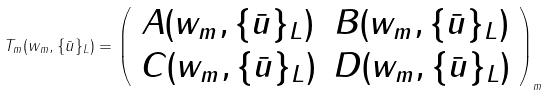<formula> <loc_0><loc_0><loc_500><loc_500>T _ { m } ( w _ { m } , \{ \bar { u } \} _ { L } ) = \left ( \begin{array} { c c } A ( w _ { m } , \{ \bar { u } \} _ { L } ) & B ( w _ { m } , \{ \bar { u } \} _ { L } ) \\ C ( w _ { m } , \{ \bar { u } \} _ { L } ) & D ( w _ { m } , \{ \bar { u } \} _ { L } ) \end{array} \right ) _ { m }</formula> 